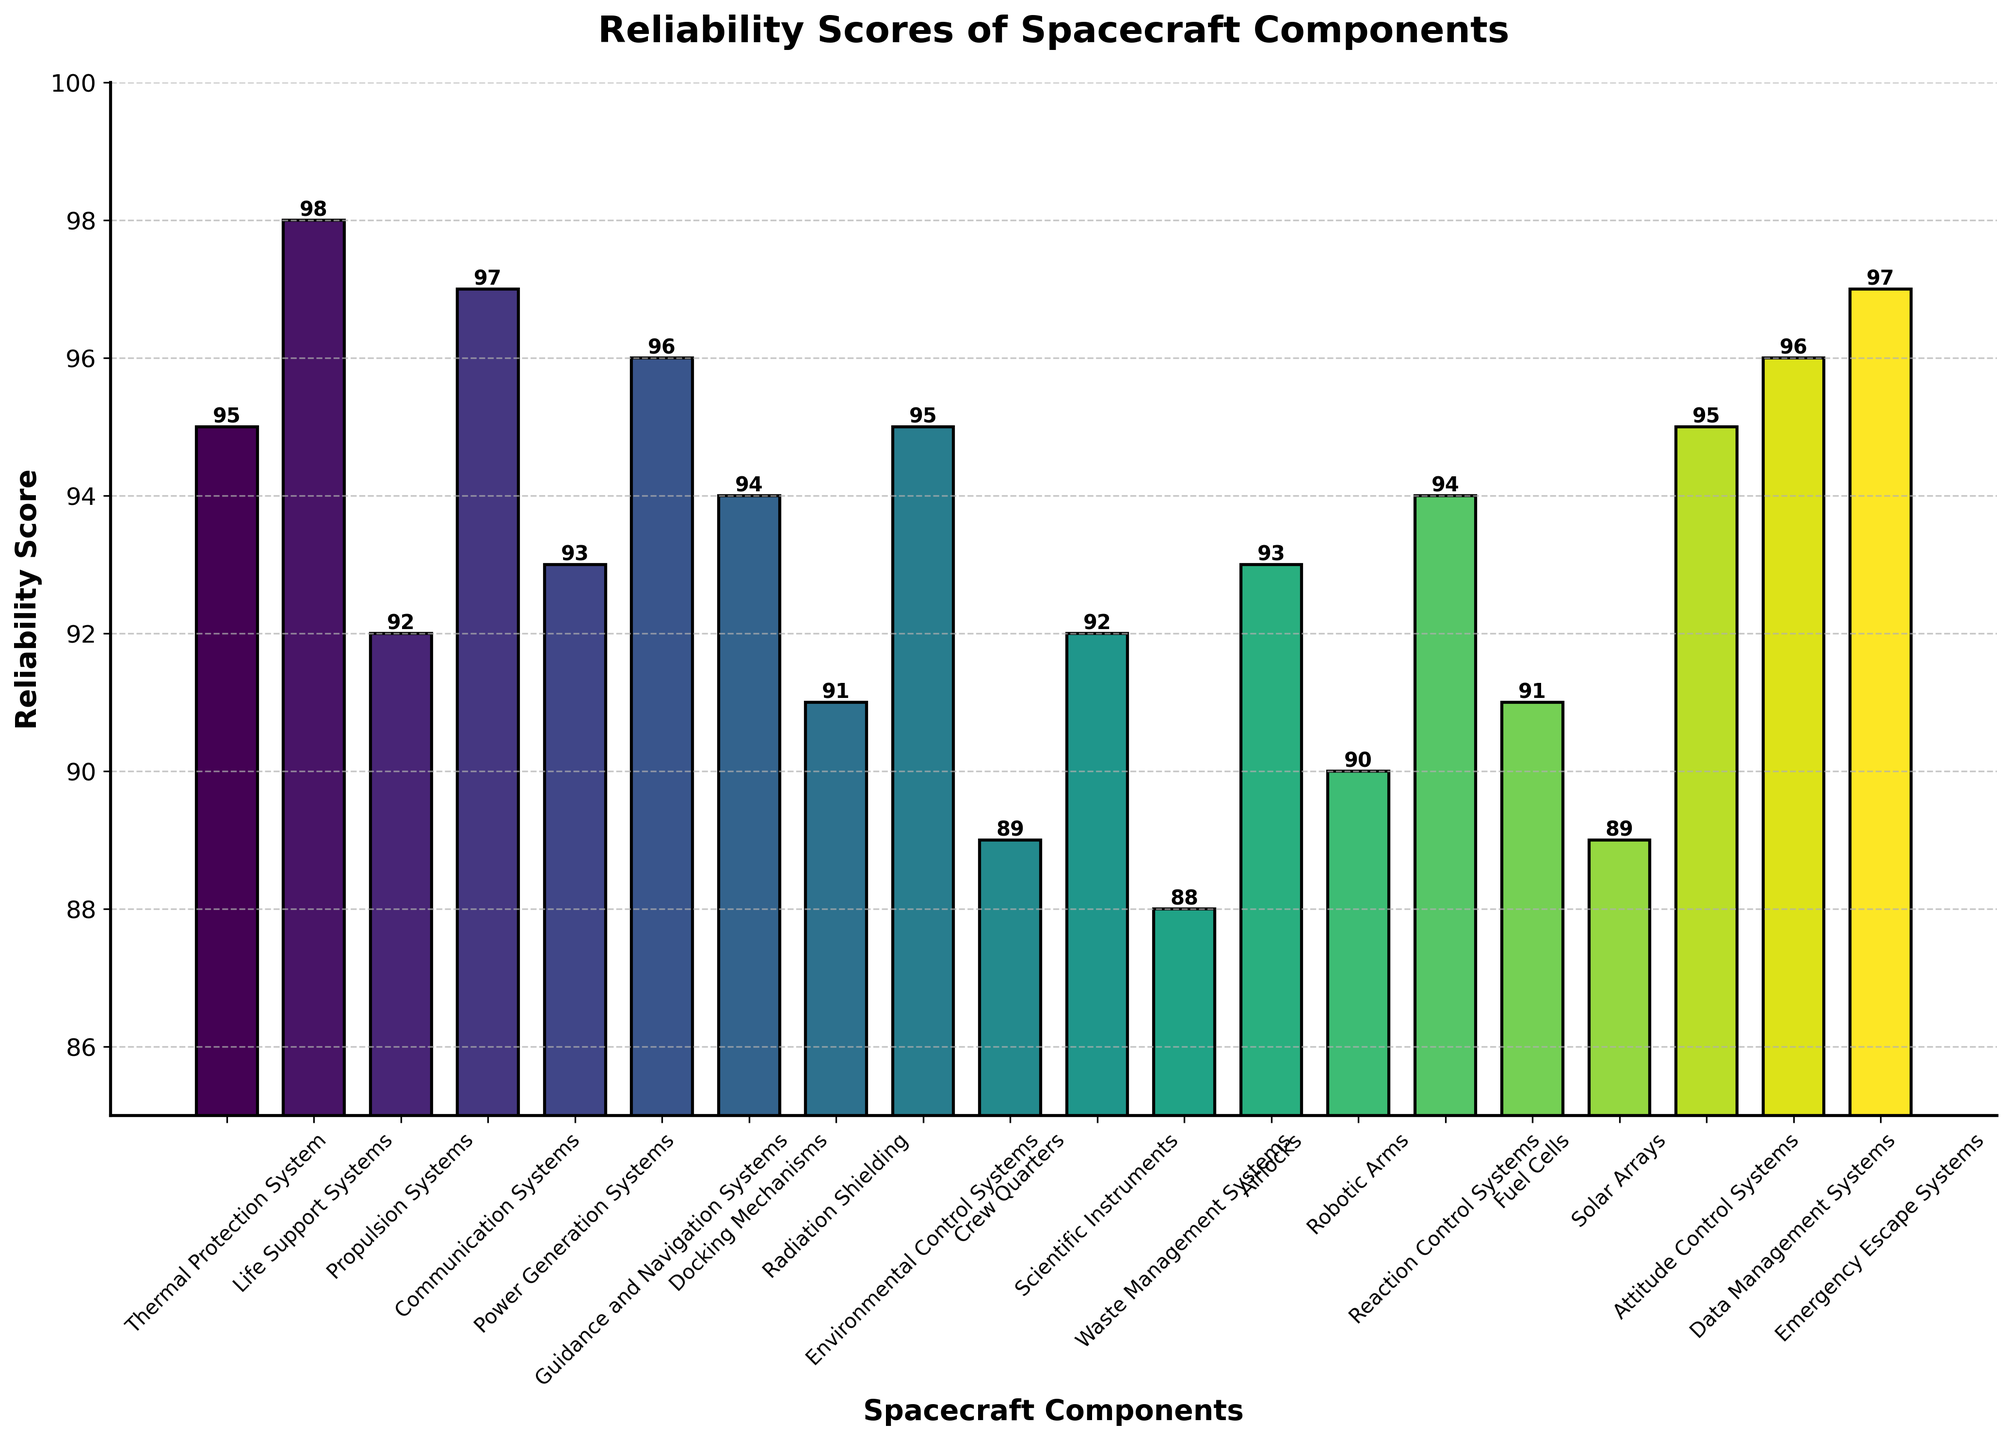Which spacecraft component has the highest reliability score? The bar with the highest value represents the Life Support Systems, which has a reliability score of 98.
Answer: Life Support Systems What is the difference in reliability scores between the Life Support Systems and the Scientific Instruments? The reliability score for Life Support Systems is 98 and for Scientific Instruments, it is 92. The difference is 98 - 92.
Answer: 6 Which components have the same reliability score? By observing the figure, the components that share the same heights are the Thermal Protection System, Environmental Control Systems, and Attitude Control Systems, each having a reliability score of 95. The same applies to Propulsion Systems and Scientific Instruments, which both have a reliability score of 92.
Answer: Thermal Protection System, Environmental Control Systems, Attitude Control Systems; Propulsion Systems, Scientific Instruments How many components have a reliability score greater than 95? By counting the bars that exceed the 95 mark, four components have reliability scores greater than 95: Life Support Systems, Communication Systems, Guidance and Navigation Systems, and Emergency Escape Systems.
Answer: 4 What is the average reliability score of the components with scores below 90? The components with scores below 90 are Crew Quarters (89), Waste Management Systems (88), and Solar Arrays (89). Their average is (89 + 88 + 89) / 3.
Answer: 88.67 Which has a higher reliability score, Docking Mechanisms or Airlocks? By comparing the heights of the bars, Docking Mechanisms have a reliability score of 94, while Airlocks have a reliability score of 93. Therefore, Docking Mechanisms have a higher reliability score.
Answer: Docking Mechanisms What is the total reliability score for all components combined? Summing up all the reliability scores from the figure: 95 + 98 + 92 + 97 + 93 + 96 + 94 + 91 + 95 + 89 + 92 + 88 + 93 + 90 + 94 + 91 + 89 + 95 + 96 + 97.
Answer: 1875 Which component's bar is just below the Communication Systems' bar in height? The bar just below the Communication Systems' bar represents the Guidance and Navigation Systems component.
Answer: Guidance and Navigation Systems What's the reliability score range of the components? The highest reliability score is 98 (Life Support Systems) and the lowest is 88 (Waste Management Systems), giving a range of 98 - 88.
Answer: 10 